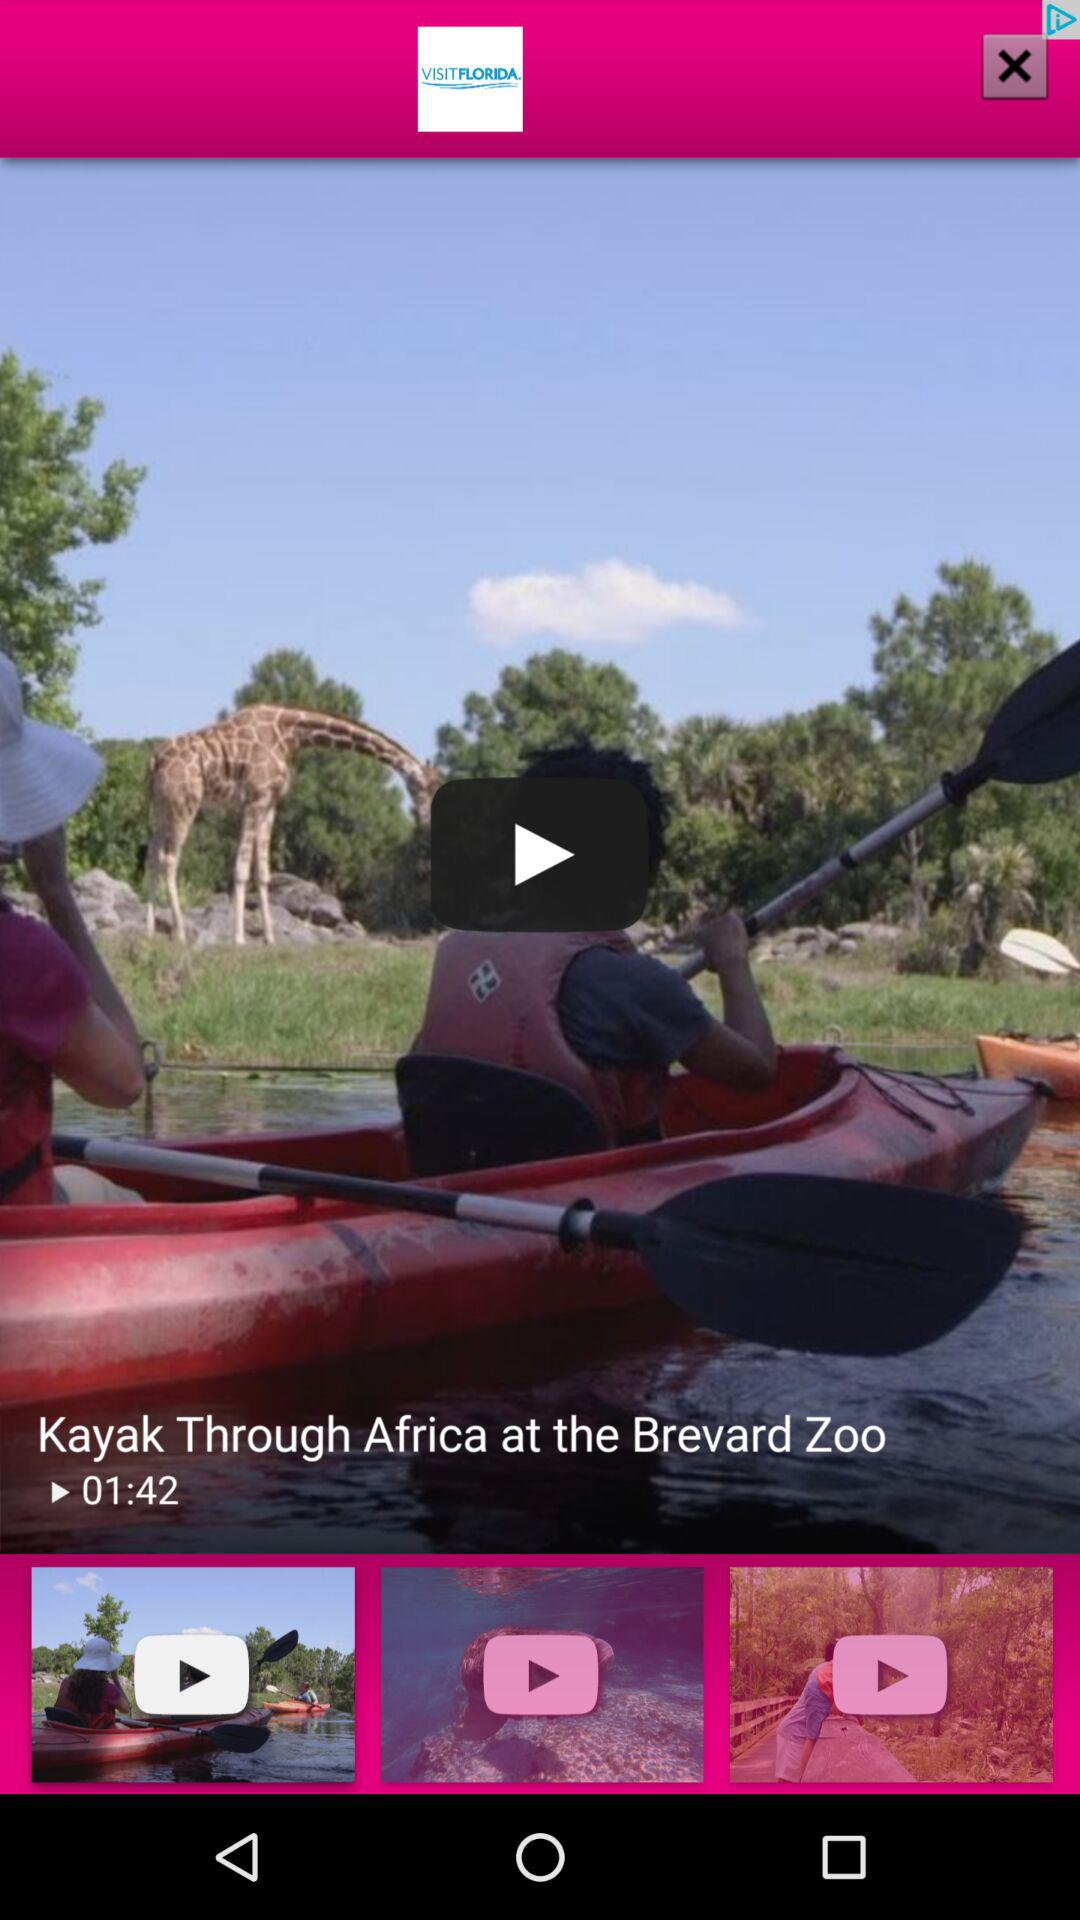Who uploaded the video?
When the provided information is insufficient, respond with <no answer>. <no answer> 